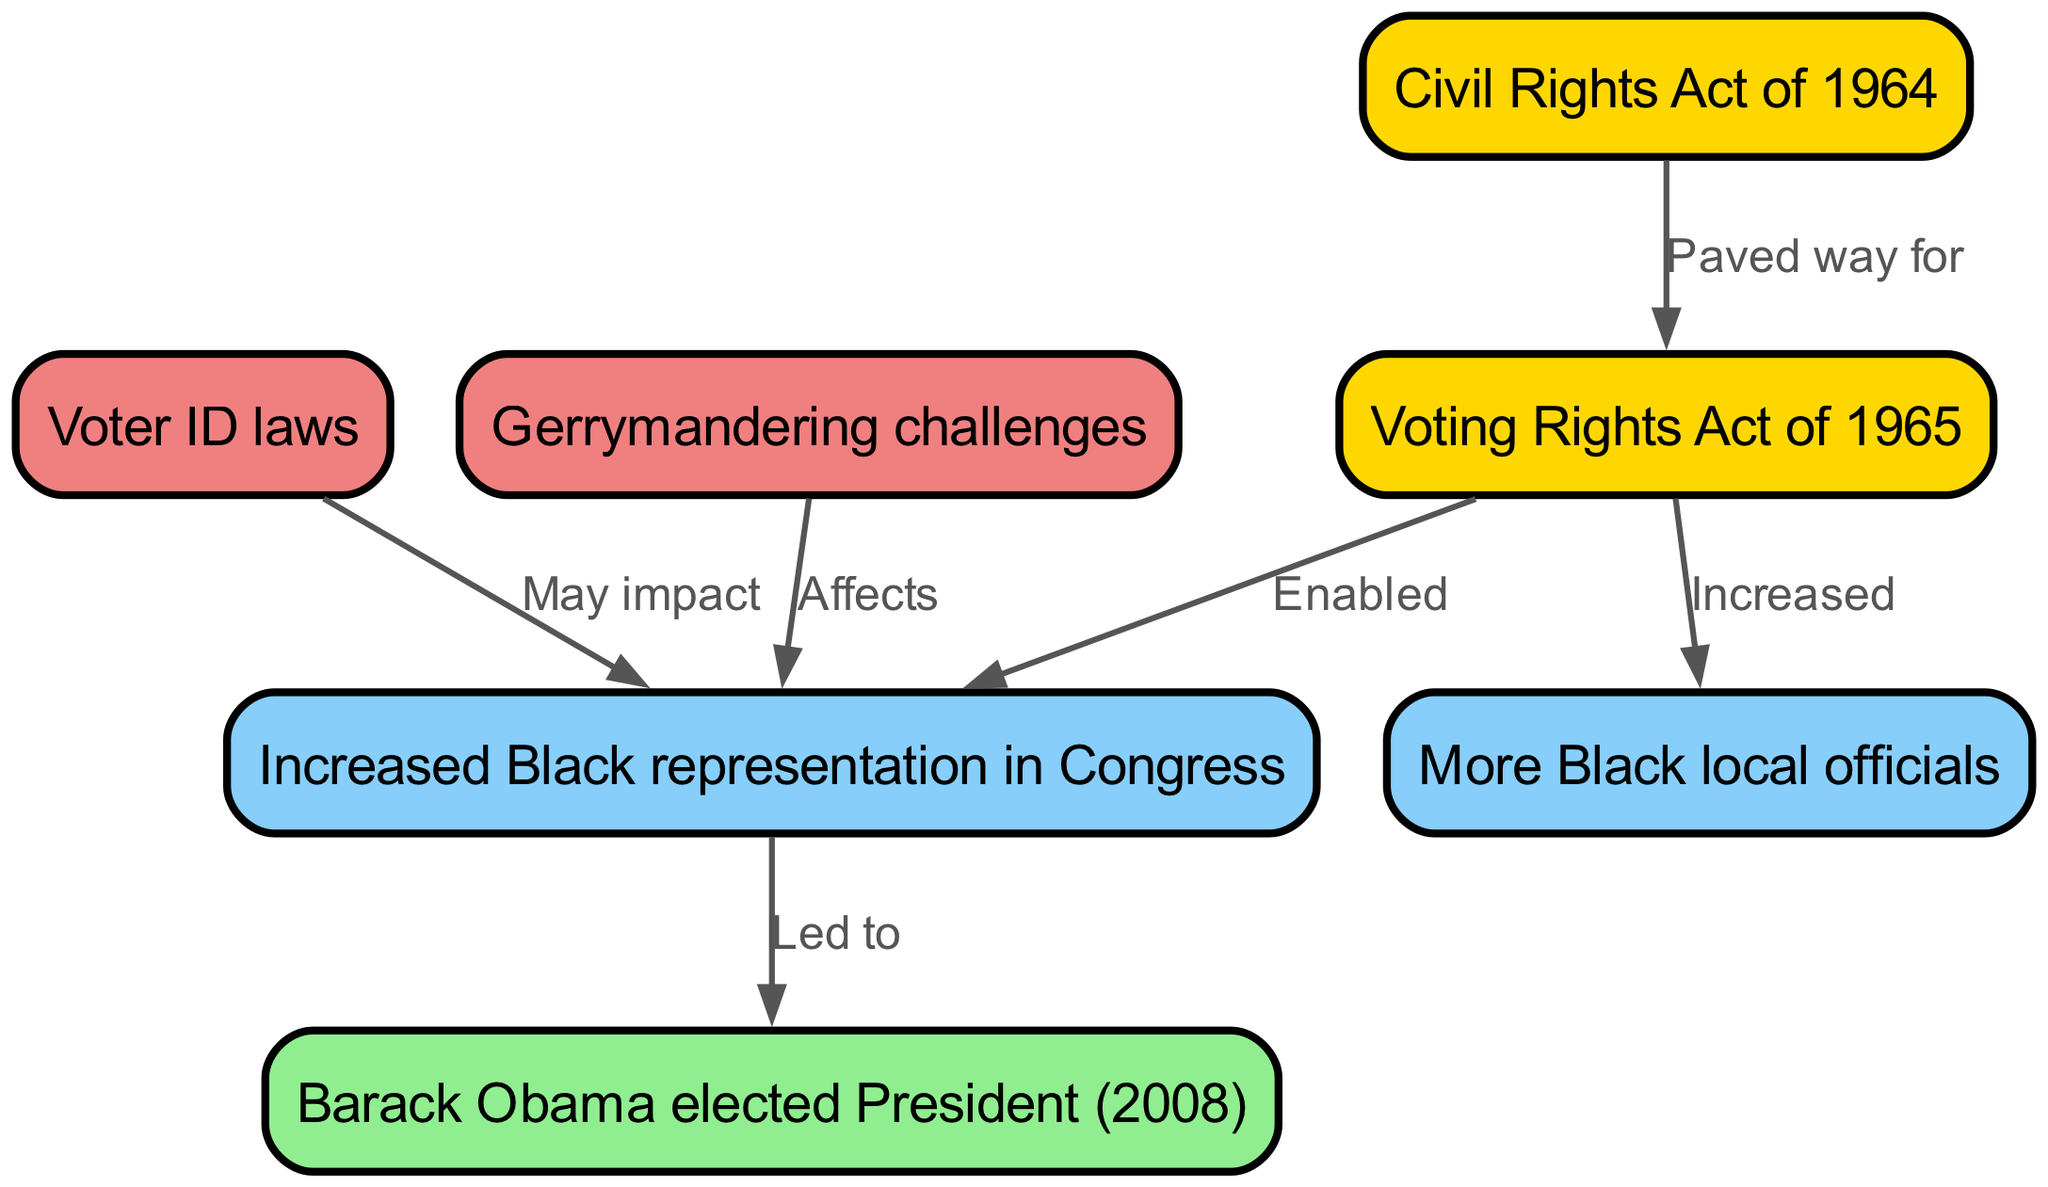What does "VRA" stand for? The node labeled "VRA" in the diagram refers to the "Voting Rights Act of 1965," which is explicitly stated in the label of that node.
Answer: Voting Rights Act of 1965 What is the relationship between "CRA" and "VRA"? The edge connecting "CRA" to "VRA" is labeled "Paved way for," indicating that the Civil Rights Act of 1964 facilitated the passing of the Voting Rights Act of 1965.
Answer: Paved way for How many nodes are present in the diagram? By counting the nodes listed in the "nodes" section of the data, there are a total of 6 nodes.
Answer: 6 What impact might "Voter ID laws" have on "Black Congress"? The edge connecting "Voter ID" to "Black Congress" is labeled "May impact," suggesting that voter ID laws could potentially affect the representation of Black individuals in Congress, although it does not specify how.
Answer: May impact Which event led to "ObamaPres"? The edge from "Black Congress" to "ObamaPres" is labeled "Led to," indicating that the increased representation of Black individuals in Congress contributed to the election of Barack Obama as President in 2008.
Answer: Led to What effect do "GerryMand" challenges have? The edge shows that "GerryMand," or gerrymandering challenges, "Affects" the "Black Congress," implying that these challenges can influence the levels of Black representation in Congress.
Answer: Affects What increased due to the "Voting Rights Act of 1965"? The edge from "VRA" to "LocalRep" is labeled "Increased," indicating that the Voting Rights Act led to an increase in Black local officials.
Answer: Increased What was a significant election milestone for African Americans in 2008? The node "ObamaPres" indicates that the election of Barack Obama as President in 2008 was a significant milestone for African Americans in political representation.
Answer: Barack Obama elected President (2008) 